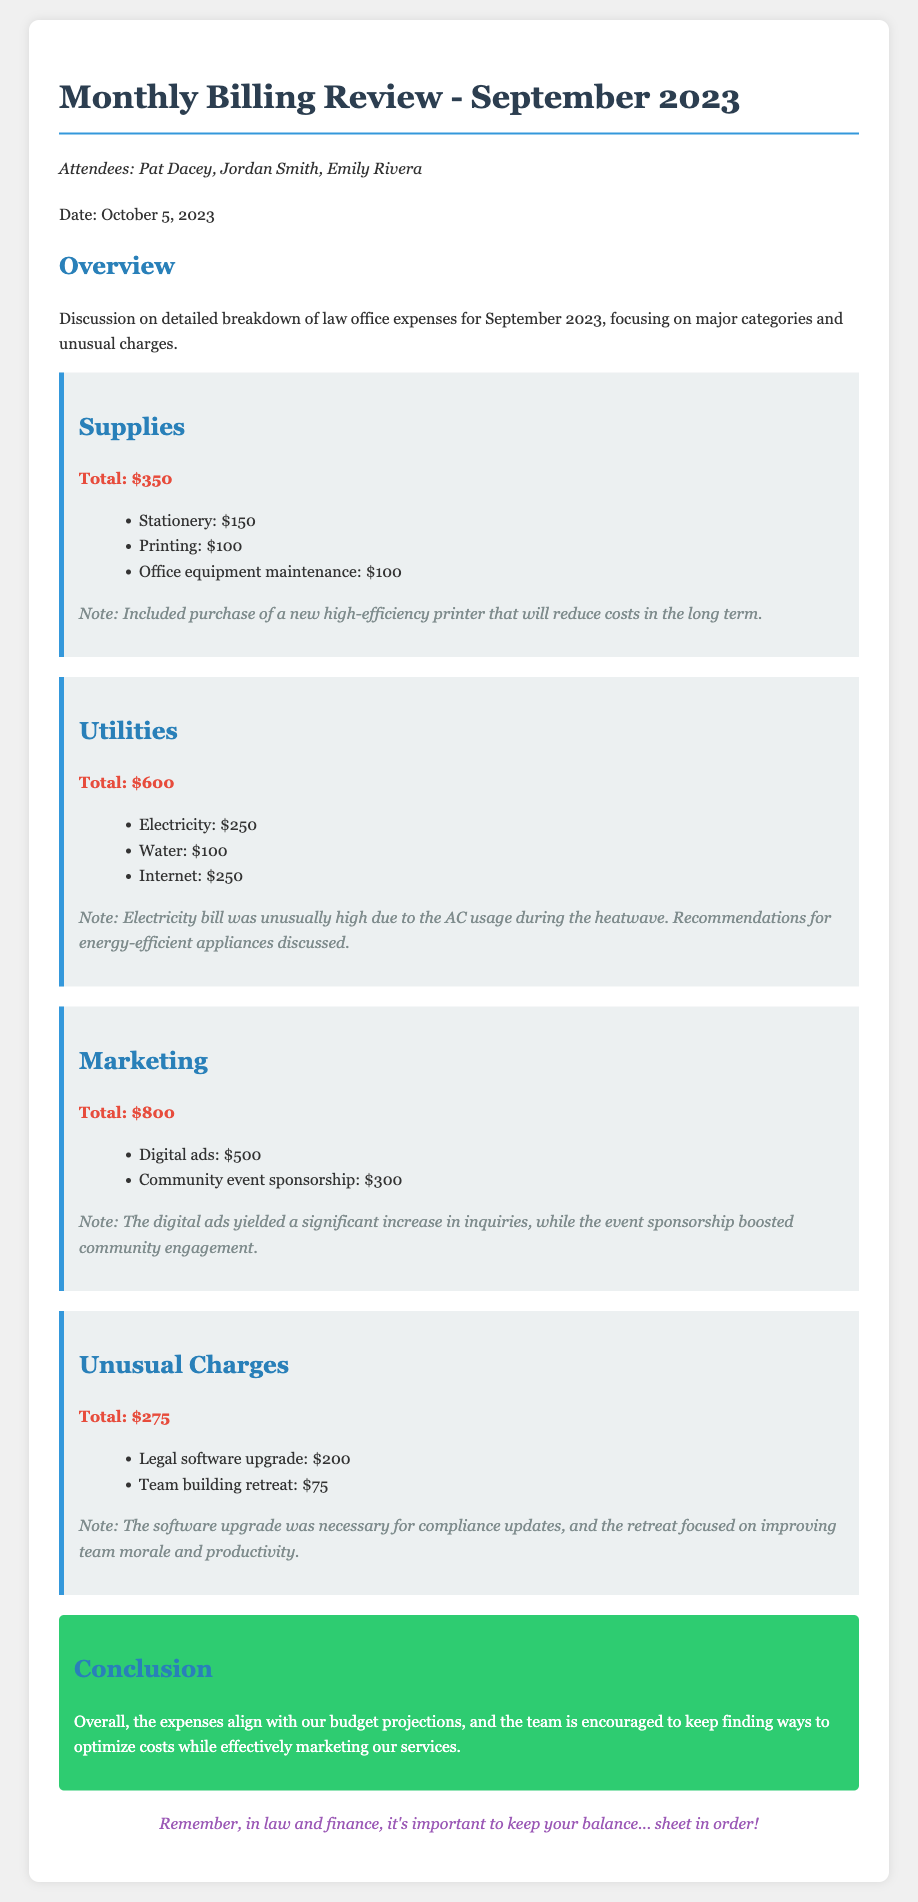What is the total expense for supplies? The total expense for supplies is mentioned as $350.
Answer: $350 What was the unusual expense related to legal software? The document notes that the legal software upgrade cost $200.
Answer: $200 Who attended the meeting? The attendees listed in the document are Pat Dacey, Jordan Smith, and Emily Rivera.
Answer: Pat Dacey, Jordan Smith, Emily Rivera What contributed to the high electricity cost? The document states that the high electricity bill was due to AC usage during the heatwave.
Answer: AC usage during the heatwave What is the total amount spent on marketing? The total expense for marketing is indicated as $800 in the document.
Answer: $800 How much was spent on the team-building retreat? The meeting minutes specify that the team building retreat cost $75.
Answer: $75 